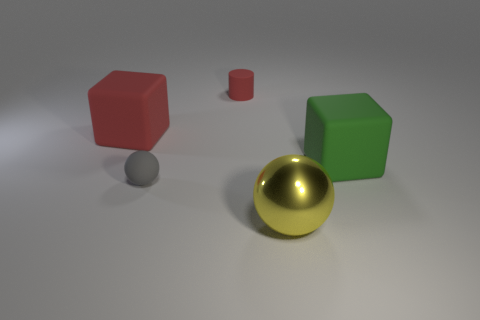Add 2 large cyan things. How many objects exist? 7 Subtract all spheres. How many objects are left? 3 Subtract all red balls. Subtract all purple cylinders. How many balls are left? 2 Subtract all gray balls. How many yellow cubes are left? 0 Subtract all gray metallic things. Subtract all large matte things. How many objects are left? 3 Add 3 large red matte blocks. How many large red matte blocks are left? 4 Add 1 big green things. How many big green things exist? 2 Subtract 0 cyan cylinders. How many objects are left? 5 